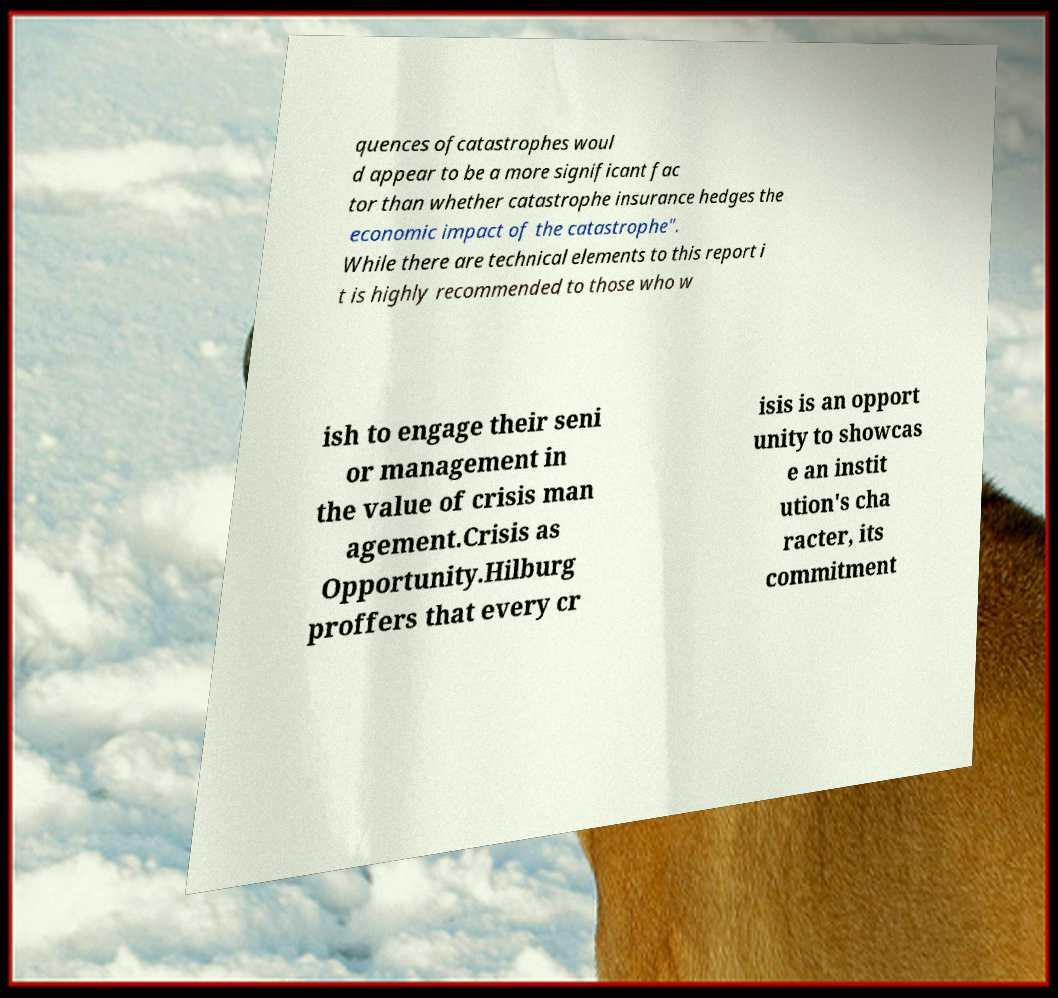I need the written content from this picture converted into text. Can you do that? quences ofcatastrophes woul d appear to be a more significant fac tor than whether catastrophe insurance hedges the economic impact of the catastrophe". While there are technical elements to this report i t is highly recommended to those who w ish to engage their seni or management in the value of crisis man agement.Crisis as Opportunity.Hilburg proffers that every cr isis is an opport unity to showcas e an instit ution's cha racter, its commitment 